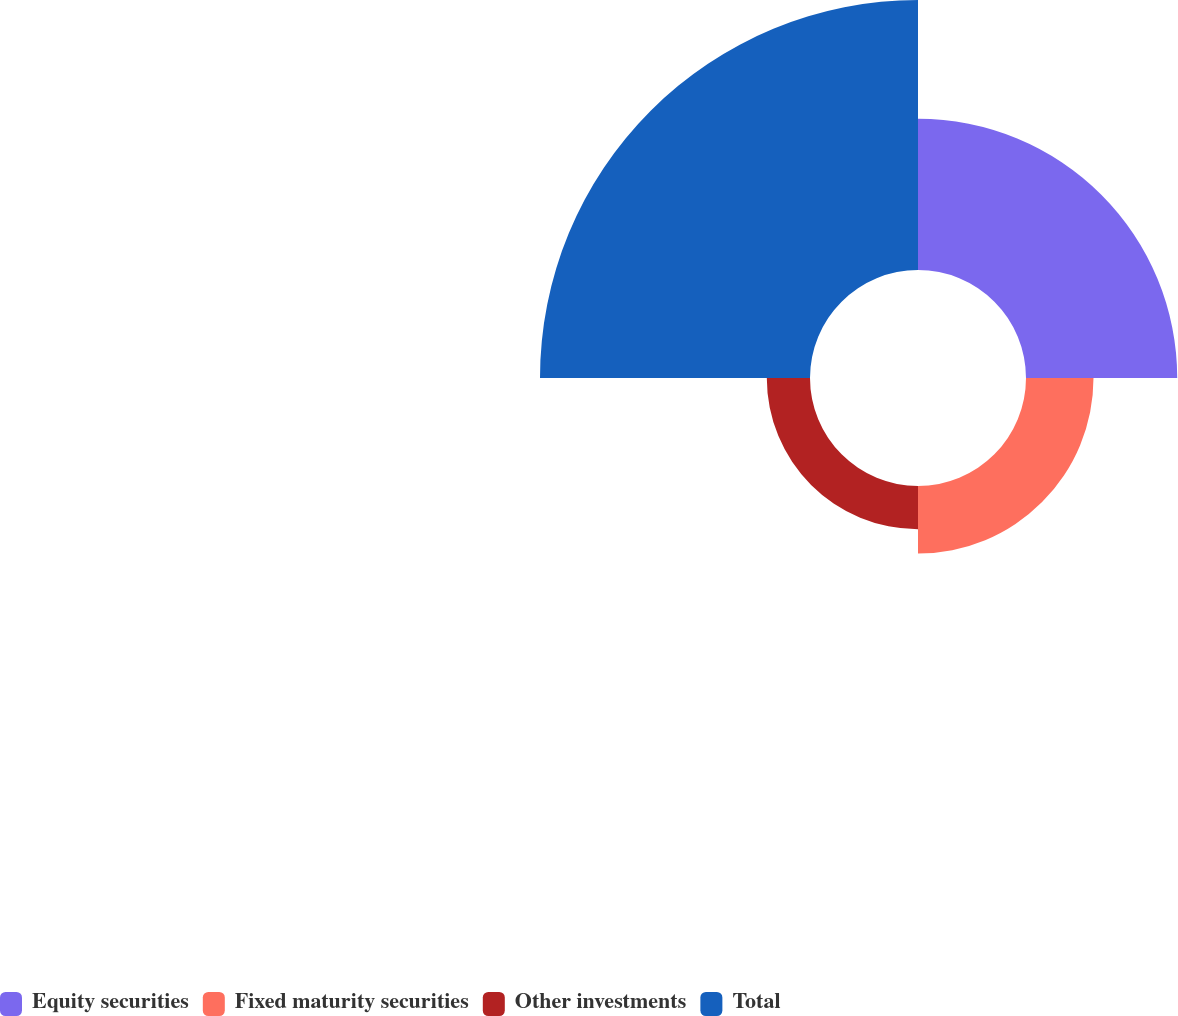Convert chart to OTSL. <chart><loc_0><loc_0><loc_500><loc_500><pie_chart><fcel>Equity securities<fcel>Fixed maturity securities<fcel>Other investments<fcel>Total<nl><fcel>28.43%<fcel>12.69%<fcel>8.12%<fcel>50.76%<nl></chart> 